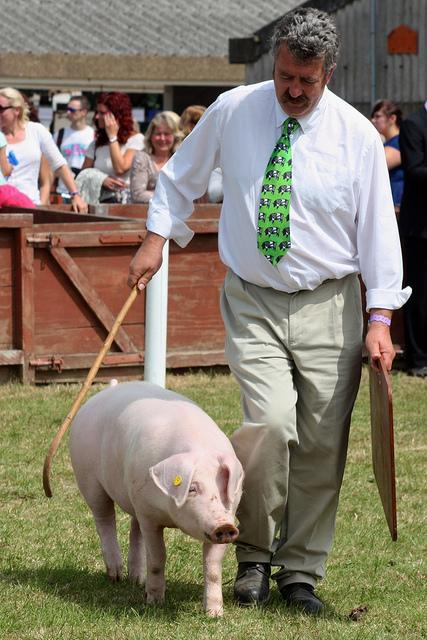What is the pig here entered in? Please explain your reasoning. show. The man dressed in business casual attire with the pig by his side and an audience viewing them indicates that they are in some sort of presentation. 